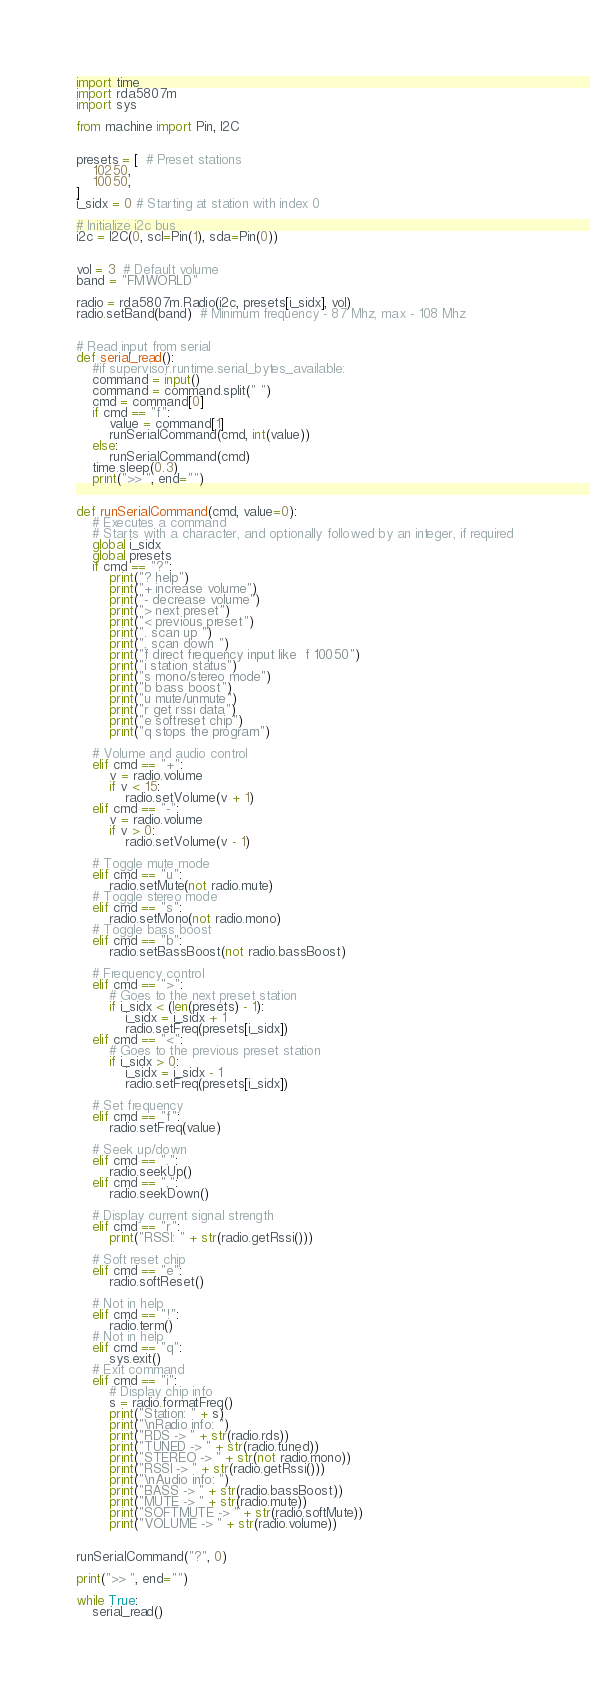Convert code to text. <code><loc_0><loc_0><loc_500><loc_500><_Python_>import time
import rda5807m
import sys

from machine import Pin, I2C


presets = [  # Preset stations
    10250,
    10050,
]
i_sidx = 0 # Starting at station with index 0

# Initialize i2c bus
i2c = I2C(0, scl=Pin(1), sda=Pin(0))


vol = 3  # Default volume
band = "FMWORLD"

radio = rda5807m.Radio(i2c, presets[i_sidx], vol)
radio.setBand(band)  # Minimum frequency - 87 Mhz, max - 108 Mhz


# Read input from serial
def serial_read():
    #if supervisor.runtime.serial_bytes_available:
    command = input()
    command = command.split(" ")
    cmd = command[0]
    if cmd == "f":
        value = command[1]
        runSerialCommand(cmd, int(value))
    else:
        runSerialCommand(cmd)
    time.sleep(0.3)
    print(">> ", end="")


def runSerialCommand(cmd, value=0):
    # Executes a command
    # Starts with a character, and optionally followed by an integer, if required
    global i_sidx
    global presets
    if cmd == "?":
        print("? help")
        print("+ increase volume")
        print("- decrease volume")
        print("> next preset")
        print("< previous preset")
        print(". scan up ")
        print(", scan down ")
        print("f direct frequency input like  f 10050")
        print("i station status")
        print("s mono/stereo mode")
        print("b bass boost")
        print("u mute/unmute")
        print("r get rssi data")
        print("e softreset chip")
        print("q stops the program")

    # Volume and audio control
    elif cmd == "+":
        v = radio.volume
        if v < 15:
            radio.setVolume(v + 1)
    elif cmd == "-":
        v = radio.volume
        if v > 0:
            radio.setVolume(v - 1)

    # Toggle mute mode
    elif cmd == "u":
        radio.setMute(not radio.mute)
    # Toggle stereo mode
    elif cmd == "s":
        radio.setMono(not radio.mono)
    # Toggle bass boost
    elif cmd == "b":
        radio.setBassBoost(not radio.bassBoost)

    # Frequency control
    elif cmd == ">":
        # Goes to the next preset station
        if i_sidx < (len(presets) - 1):
            i_sidx = i_sidx + 1
            radio.setFreq(presets[i_sidx])
    elif cmd == "<":
        # Goes to the previous preset station
        if i_sidx > 0:
            i_sidx = i_sidx - 1
            radio.setFreq(presets[i_sidx])

    # Set frequency
    elif cmd == "f":
        radio.setFreq(value)

    # Seek up/down
    elif cmd == ".":
        radio.seekUp()
    elif cmd == ",":
        radio.seekDown()

    # Display current signal strength
    elif cmd == "r":
        print("RSSI: " + str(radio.getRssi()))

    # Soft reset chip
    elif cmd == "e":
        radio.softReset()

    # Not in help
    elif cmd == "!":
        radio.term()
    # Not in help
    elif cmd == "q":
        sys.exit()
    # Exit command
    elif cmd == "i":
        # Display chip info
        s = radio.formatFreq()
        print("Station: " + s)
        print("\nRadio info: ")
        print("RDS -> " + str(radio.rds))
        print("TUNED -> " + str(radio.tuned))
        print("STEREO -> " + str(not radio.mono))
        print("RSSI -> " + str(radio.getRssi()))
        print("\nAudio info: ")
        print("BASS -> " + str(radio.bassBoost))
        print("MUTE -> " + str(radio.mute))
        print("SOFTMUTE -> " + str(radio.softMute))
        print("VOLUME -> " + str(radio.volume))
        

runSerialCommand("?", 0)

print(">> ", end="")

while True:
    serial_read()</code> 